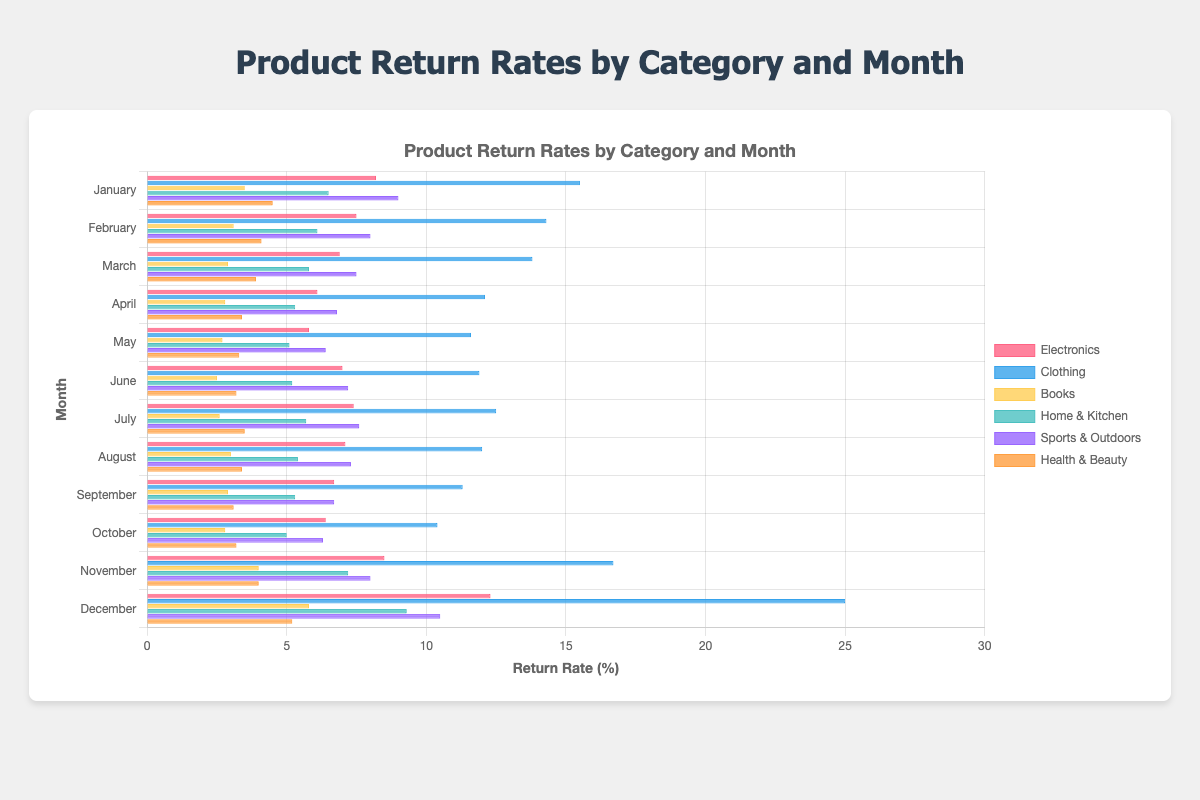what is the return rate of Electronics in November compared to January? January's return rate for Electronics is 8.2%, and November's is 8.5%, so the return rate in November is slightly higher.
Answer: November's rate (8.5%) is higher than January's (8.2%) Which product category has the highest return rate in December? To determine this, compare the return rates of all categories in December. Electronics is at 12.3%, Clothing at 25.0%, Books at 5.8%, Home & Kitchen at 9.3%, Sports & Outdoors at 10.5%, and Health & Beauty at 5.2%.
Answer: Clothing with 25.0% What's the average return rate for Books in the first quarter (January, February, March)? Sum the return rates for Books in January (3.5%), February (3.1%), and March (2.9%), which equals 9.5%. Then, divide by 3 (the number of months) to find the average.
Answer: 3.17% What is the difference in return rates between June and July for Sports & Outdoors? Sports & Outdoors return rate for June is 7.2% and for July is 7.6%. The difference is calculated by subtracting 7.2 from 7.6.
Answer: 0.4% Which month has the lowest return rate for Health & Beauty, and what is the rate? Review the return rates for each month in Health & Beauty, where the lowest is in September at 3.1%.
Answer: September with 3.1% By how much did the return rate for Clothing increase from October to November? The return rate for Clothing in October is 10.4% and in November is 16.7%, so the increase is calculated by subtracting 10.4 from 16.7.
Answer: 6.3% What is the median return rate for Home & Kitchen across all months? Organize the twelve monthly return rates for Home & Kitchen and find the middle values, then calculate their average: (5.2 + 5.3)/2 = 5.25.
Answer: 5.25% Which product category has the least variation in return rates throughout the year? Evaluate the stability of return rates for each product category across all months. Books’ return rates range between 2.5% and 5.8%, showing the least variation.
Answer: Books Determine the month with the highest average return rate across all product categories. Sum the return rates for each month across all product categories and find the month with the highest total before averaging. For December, the total is 12.3 (Electronics) + 25.0 (Clothing) + 5.8 (Books) + 9.3 (Home & Kitchen) + 10.5 (Sports & Outdoors) + 5.2 (Health & Beauty) = 68.1. Divide by 6 (number of categories).
Answer: December (68.1/6 ≈ 11.35) Compare any trends in the return rates between Health & Beauty and Books. Analyze and describe the pattern across months; both categories have lower return rates throughout the year with peaks in November and December, but Health & Beauty's rates are slightly higher overall.
Answer: Both categories show increasing return rates towards the end of the year 